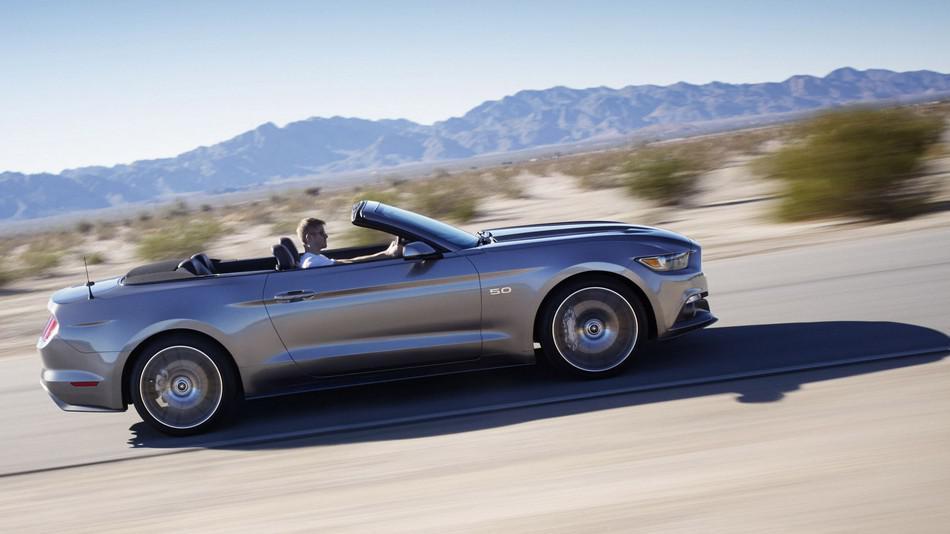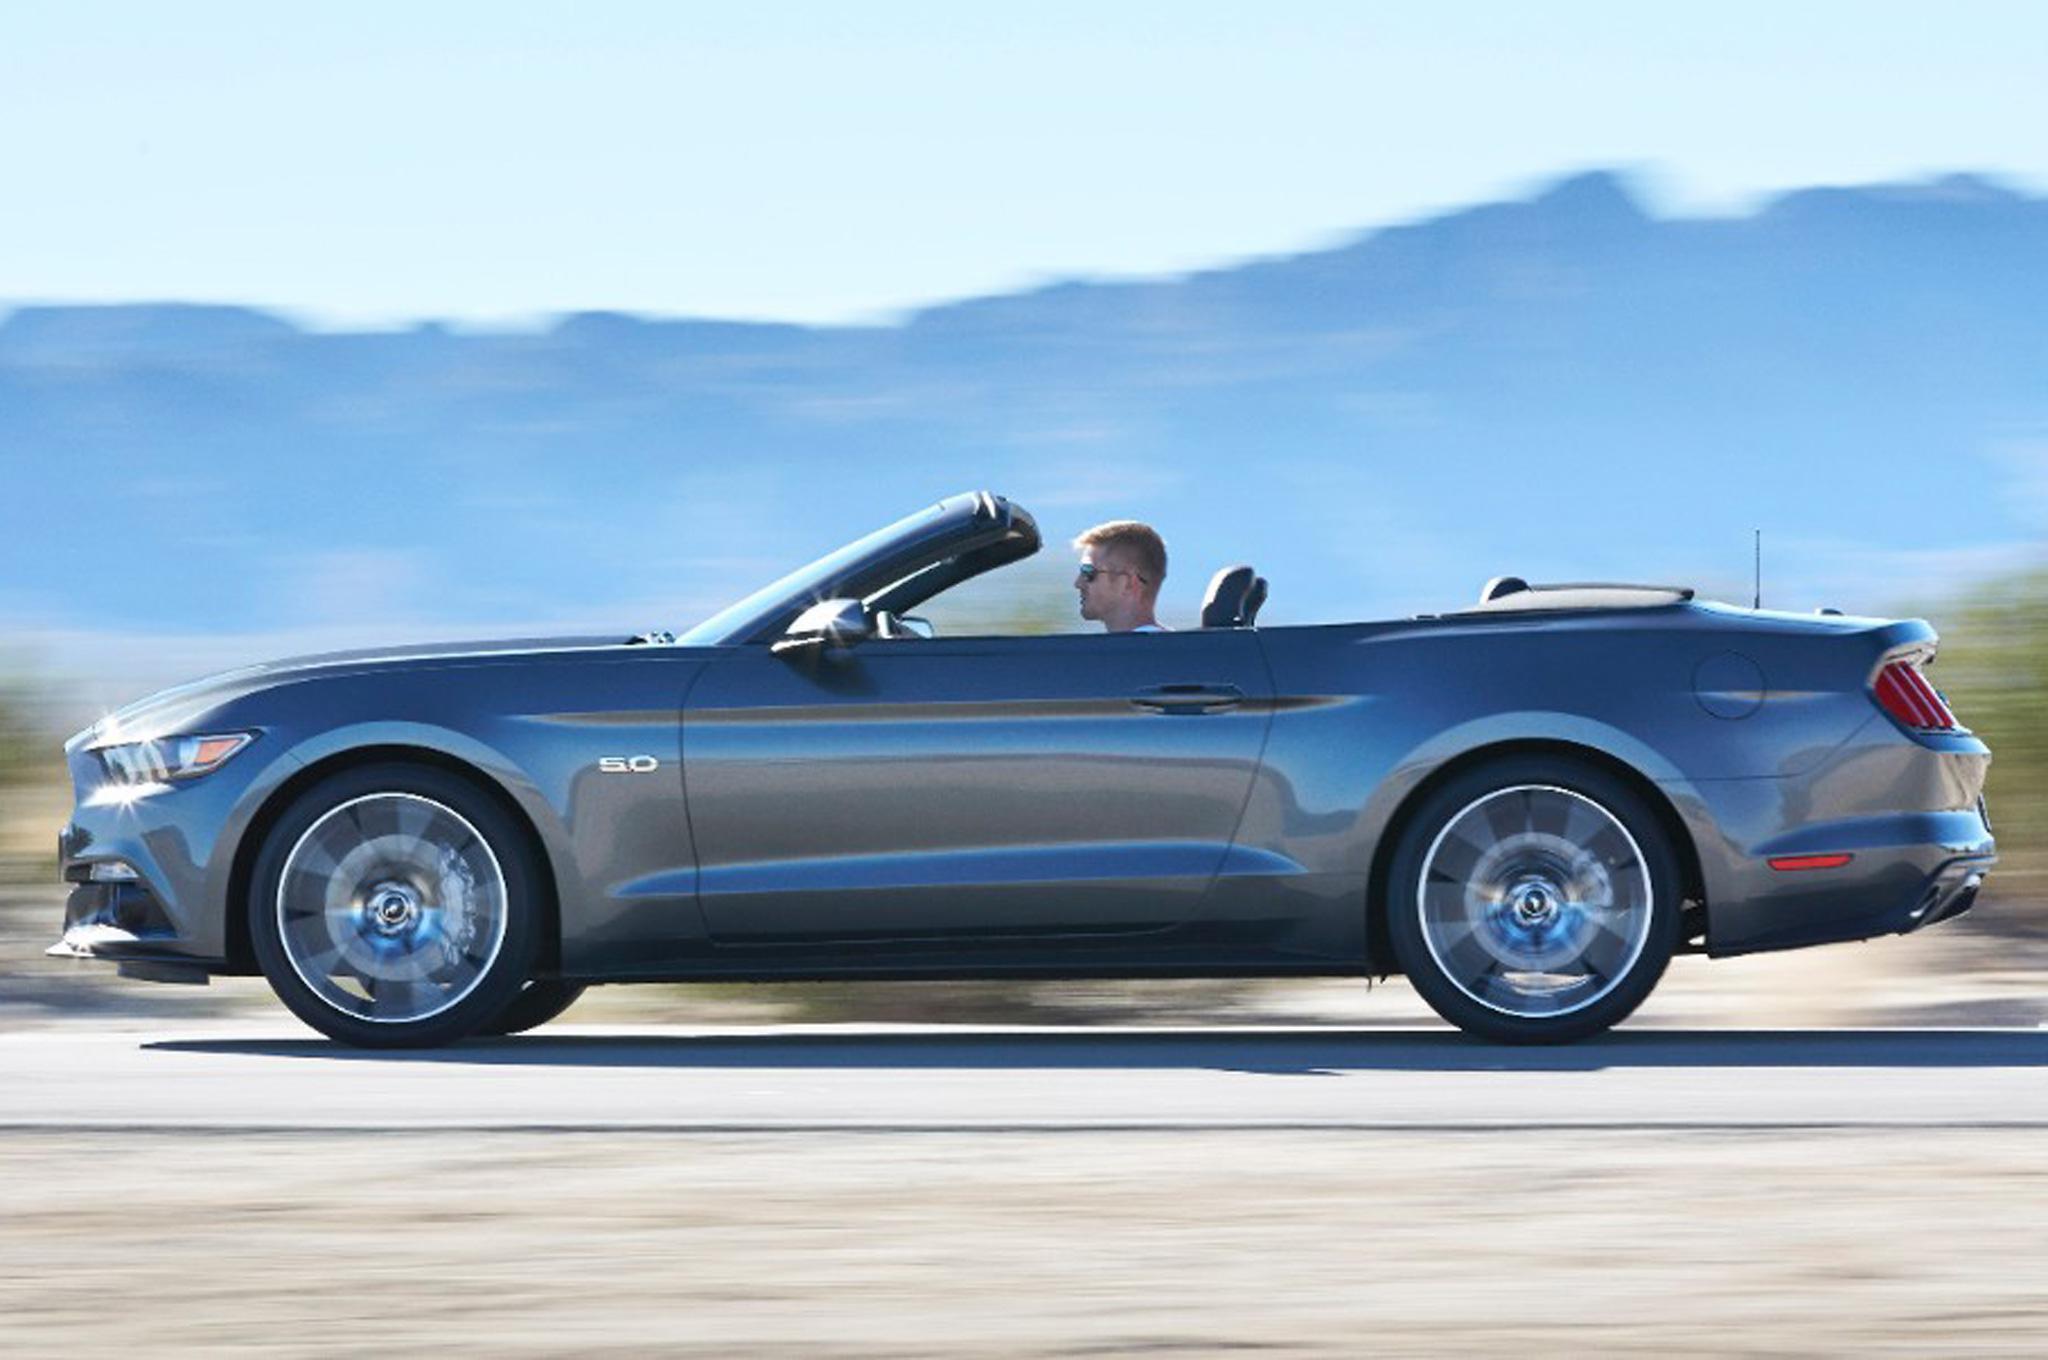The first image is the image on the left, the second image is the image on the right. For the images displayed, is the sentence "One of the convertibles doesn't have the top removed." factually correct? Answer yes or no. No. 